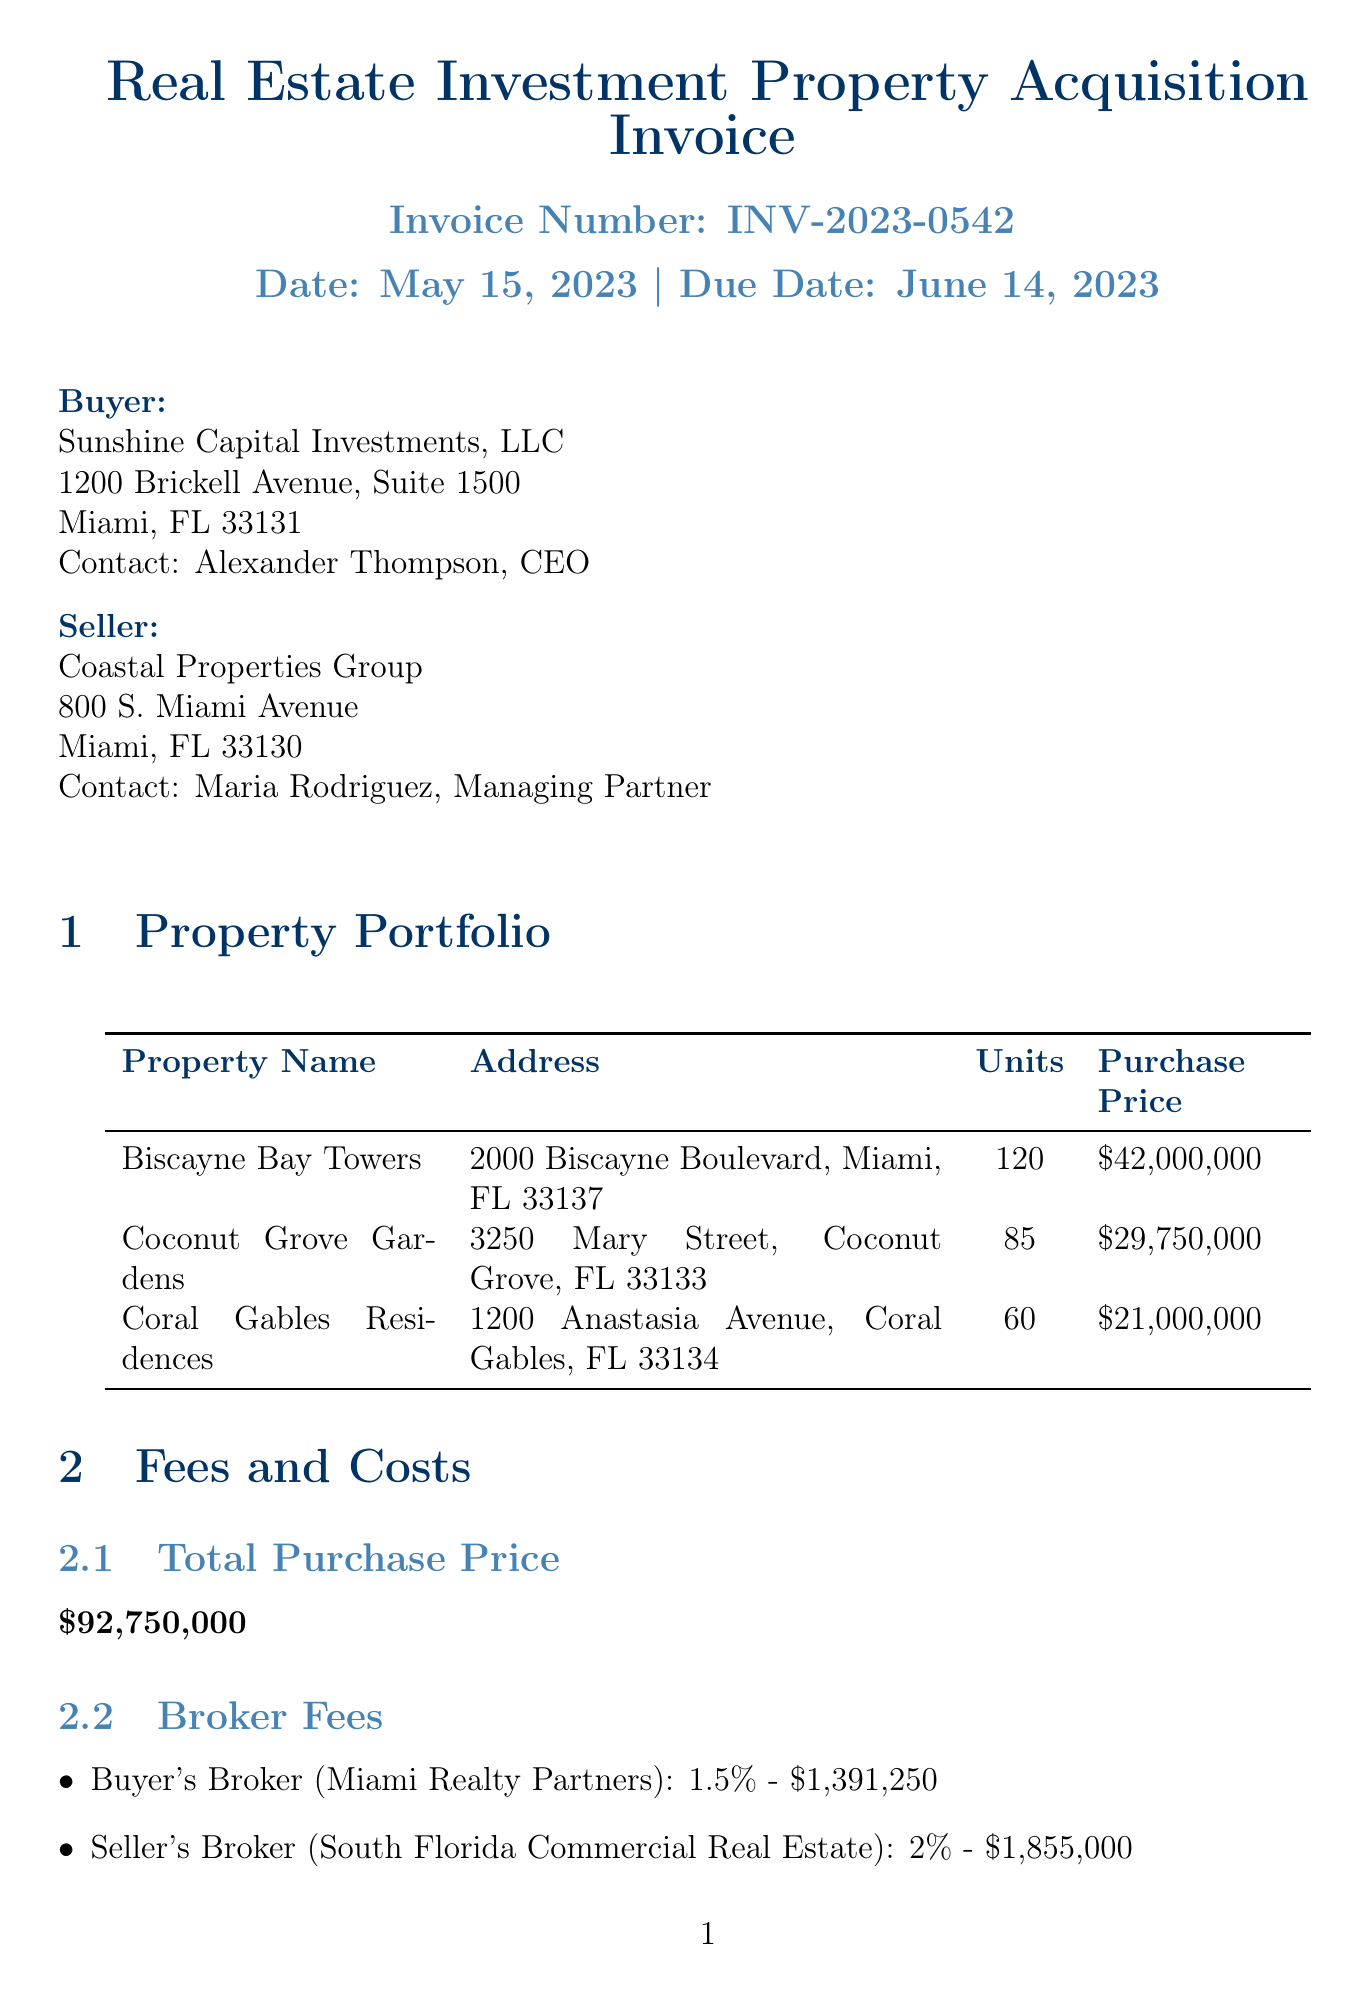What is the invoice number? The invoice number can be found in the document, specifically listed at the beginning.
Answer: INV-2023-0542 Who is the buyer? The buyer's information is provided in the document and includes the company's name.
Answer: Sunshine Capital Investments, LLC What is the total purchase price? The total purchase price is explicitly mentioned in the fees and costs section of the document.
Answer: $92,750,000 How many units are in Coral Gables Residences? The number of units is detailed in the property portfolio section for that specific property.
Answer: 60 What is the closing cost for title insurance? The closing costs include specific amounts for different fees, with title insurance being one of them.
Answer: $463,750 What is the interest rate of the loan? The interest rate is found in the financing section and is specified clearly.
Answer: 4.25% How many properties are listed in the property portfolio? The property portfolio lists multiple properties, showing how many are documented.
Answer: 3 What is the due date for the invoice? The due date is noted at the top of the document, along with the invoice date.
Answer: June 14, 2023 What is the total due amount? The total due is shown prominently at the end of the document, specifying the full amount owed.
Answer: $96,661,000 